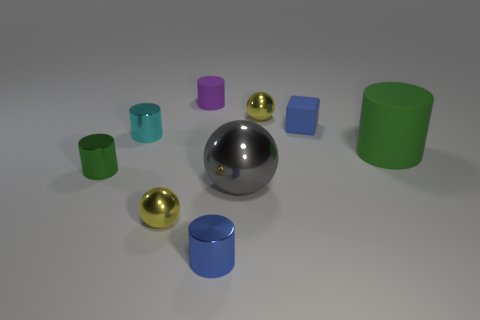Are the block and the tiny yellow thing that is in front of the cyan cylinder made of the same material?
Your answer should be compact. No. The small thing that is behind the small matte block and in front of the purple cylinder has what shape?
Your response must be concise. Sphere. Is the small green thing the same shape as the cyan metallic thing?
Provide a succinct answer. Yes. The large object that is made of the same material as the cyan cylinder is what shape?
Give a very brief answer. Sphere. What material is the yellow sphere in front of the big green cylinder that is on the right side of the blue rubber cube to the right of the green metal cylinder made of?
Keep it short and to the point. Metal. What number of objects are rubber things right of the blue metallic cylinder or tiny purple blocks?
Your answer should be compact. 2. How many other objects are there of the same shape as the purple object?
Offer a very short reply. 4. Are there more small metal balls in front of the small cyan cylinder than large yellow rubber cylinders?
Make the answer very short. Yes. What is the size of the green matte object that is the same shape as the tiny cyan metal object?
Your response must be concise. Large. The blue matte thing has what shape?
Keep it short and to the point. Cube. 